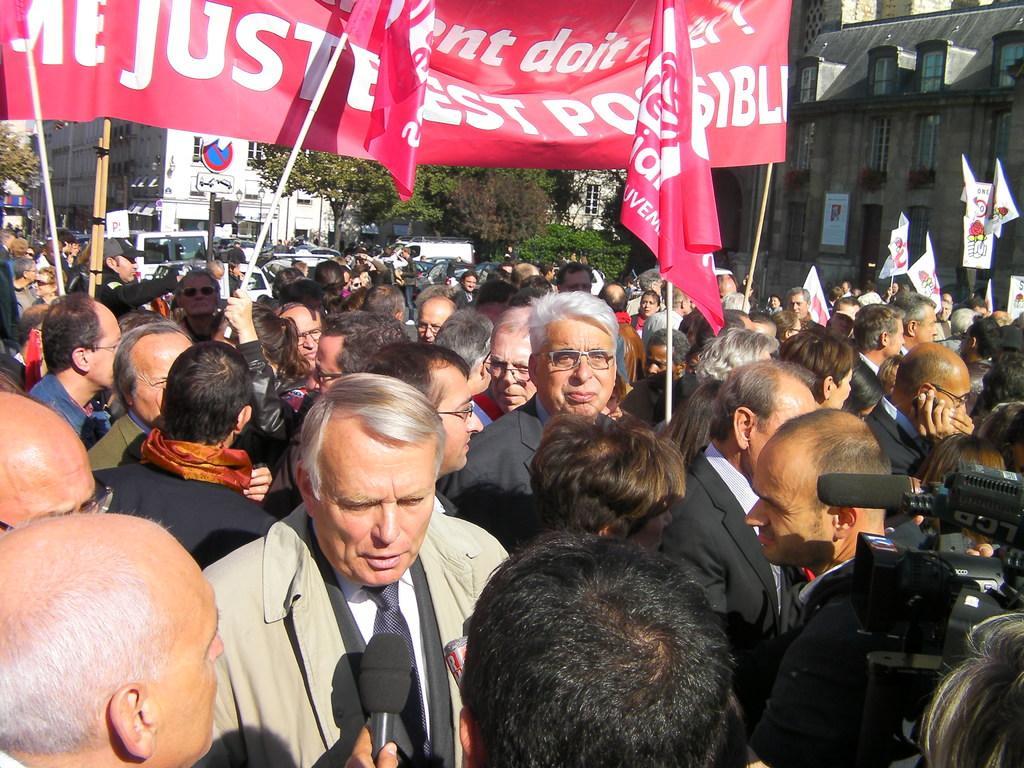Please provide a concise description of this image. In this picture there are people and we can see banners and microphone. In the background of the image we can see buildings, trees, board on pole and vehicles. 